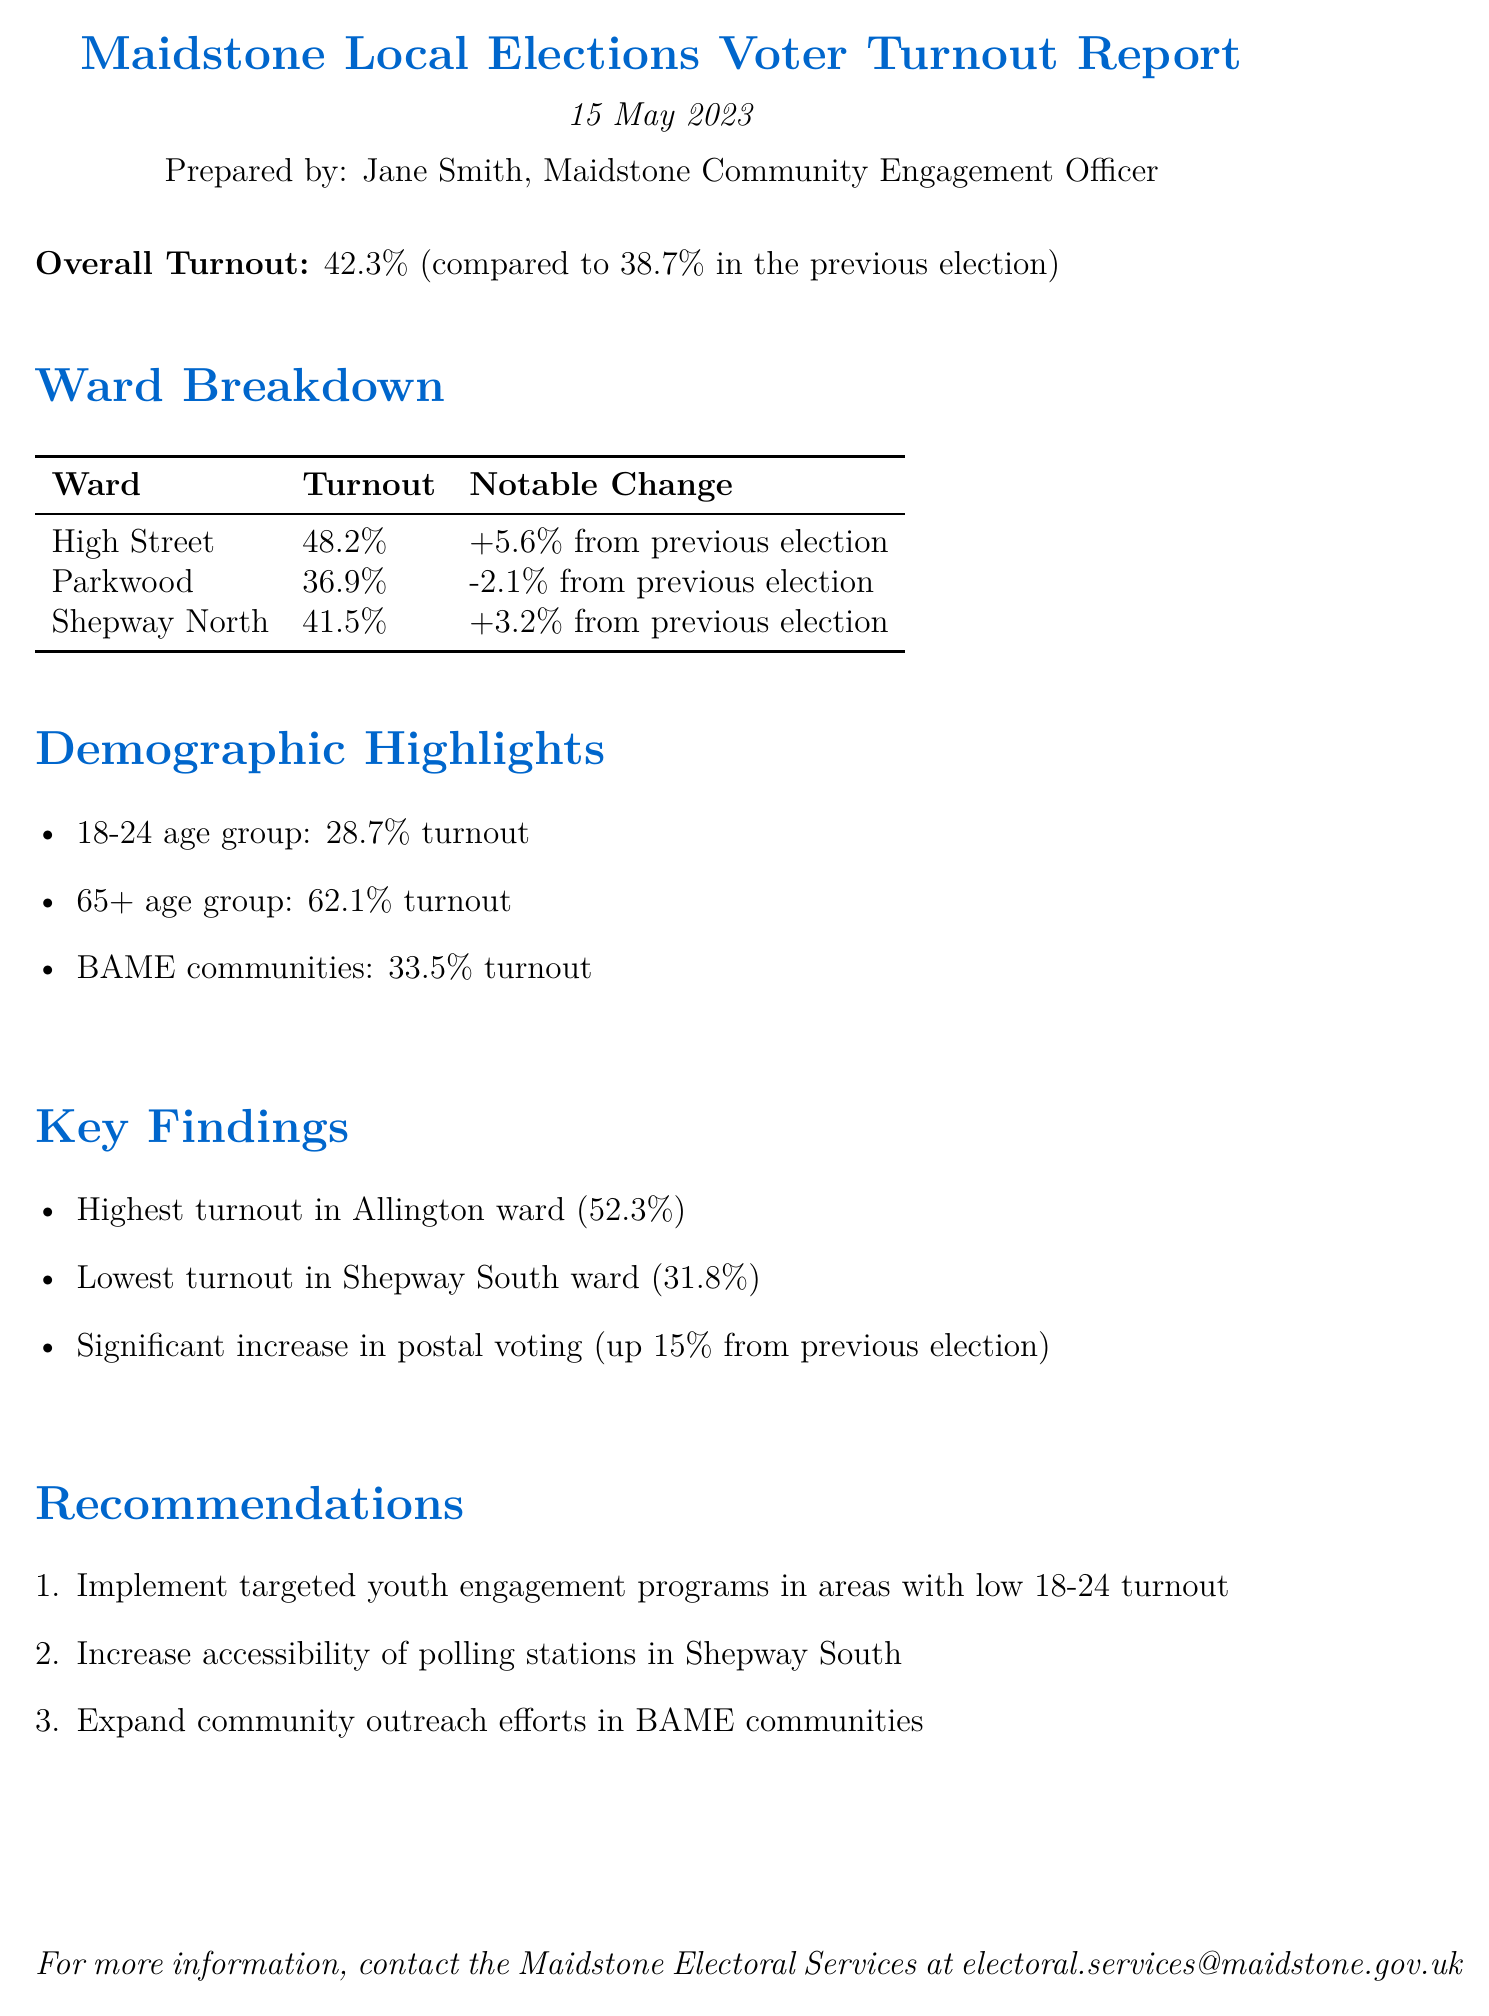What is the overall voter turnout percentage? The overall voter turnout is stated explicitly at the beginning of the report.
Answer: 42.3% Which ward had the highest turnout? The ward with the highest turnout is highlighted in the Key Findings section.
Answer: Allington What was the turnout for the 18-24 age group? The turnout percentage for the 18-24 age group is listed in the Demographic Highlights section.
Answer: 28.7% What notable change did High Street ward experience? The notable change for High Street ward is indicated in the Ward Breakdown table.
Answer: +5.6% What demographic has the lowest turnout rate? The lowest turnout is found by comparing the demographic highlights listed in the report.
Answer: 18-24 age group What recommendation is made for areas with low youth turnout? The recommendation for youth engagement is mentioned in the Recommendations section of the report.
Answer: Implement targeted youth engagement programs What was the increase in postal voting from the previous election? The increase in postal voting is included in the Key Findings of the document.
Answer: Up 15% What is the email contact for Maidstone Electoral Services? The contact email is provided at the end of the report for further inquiries.
Answer: electoral.services@maidstone.gov.uk 